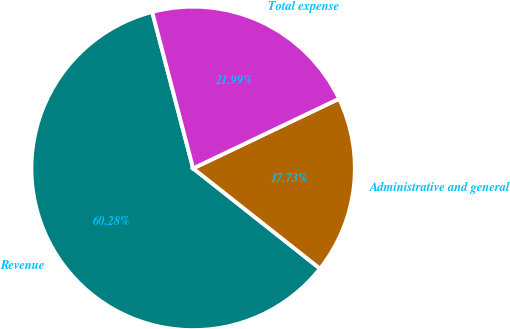<chart> <loc_0><loc_0><loc_500><loc_500><pie_chart><fcel>Revenue<fcel>Administrative and general<fcel>Total expense<nl><fcel>60.28%<fcel>17.73%<fcel>21.99%<nl></chart> 